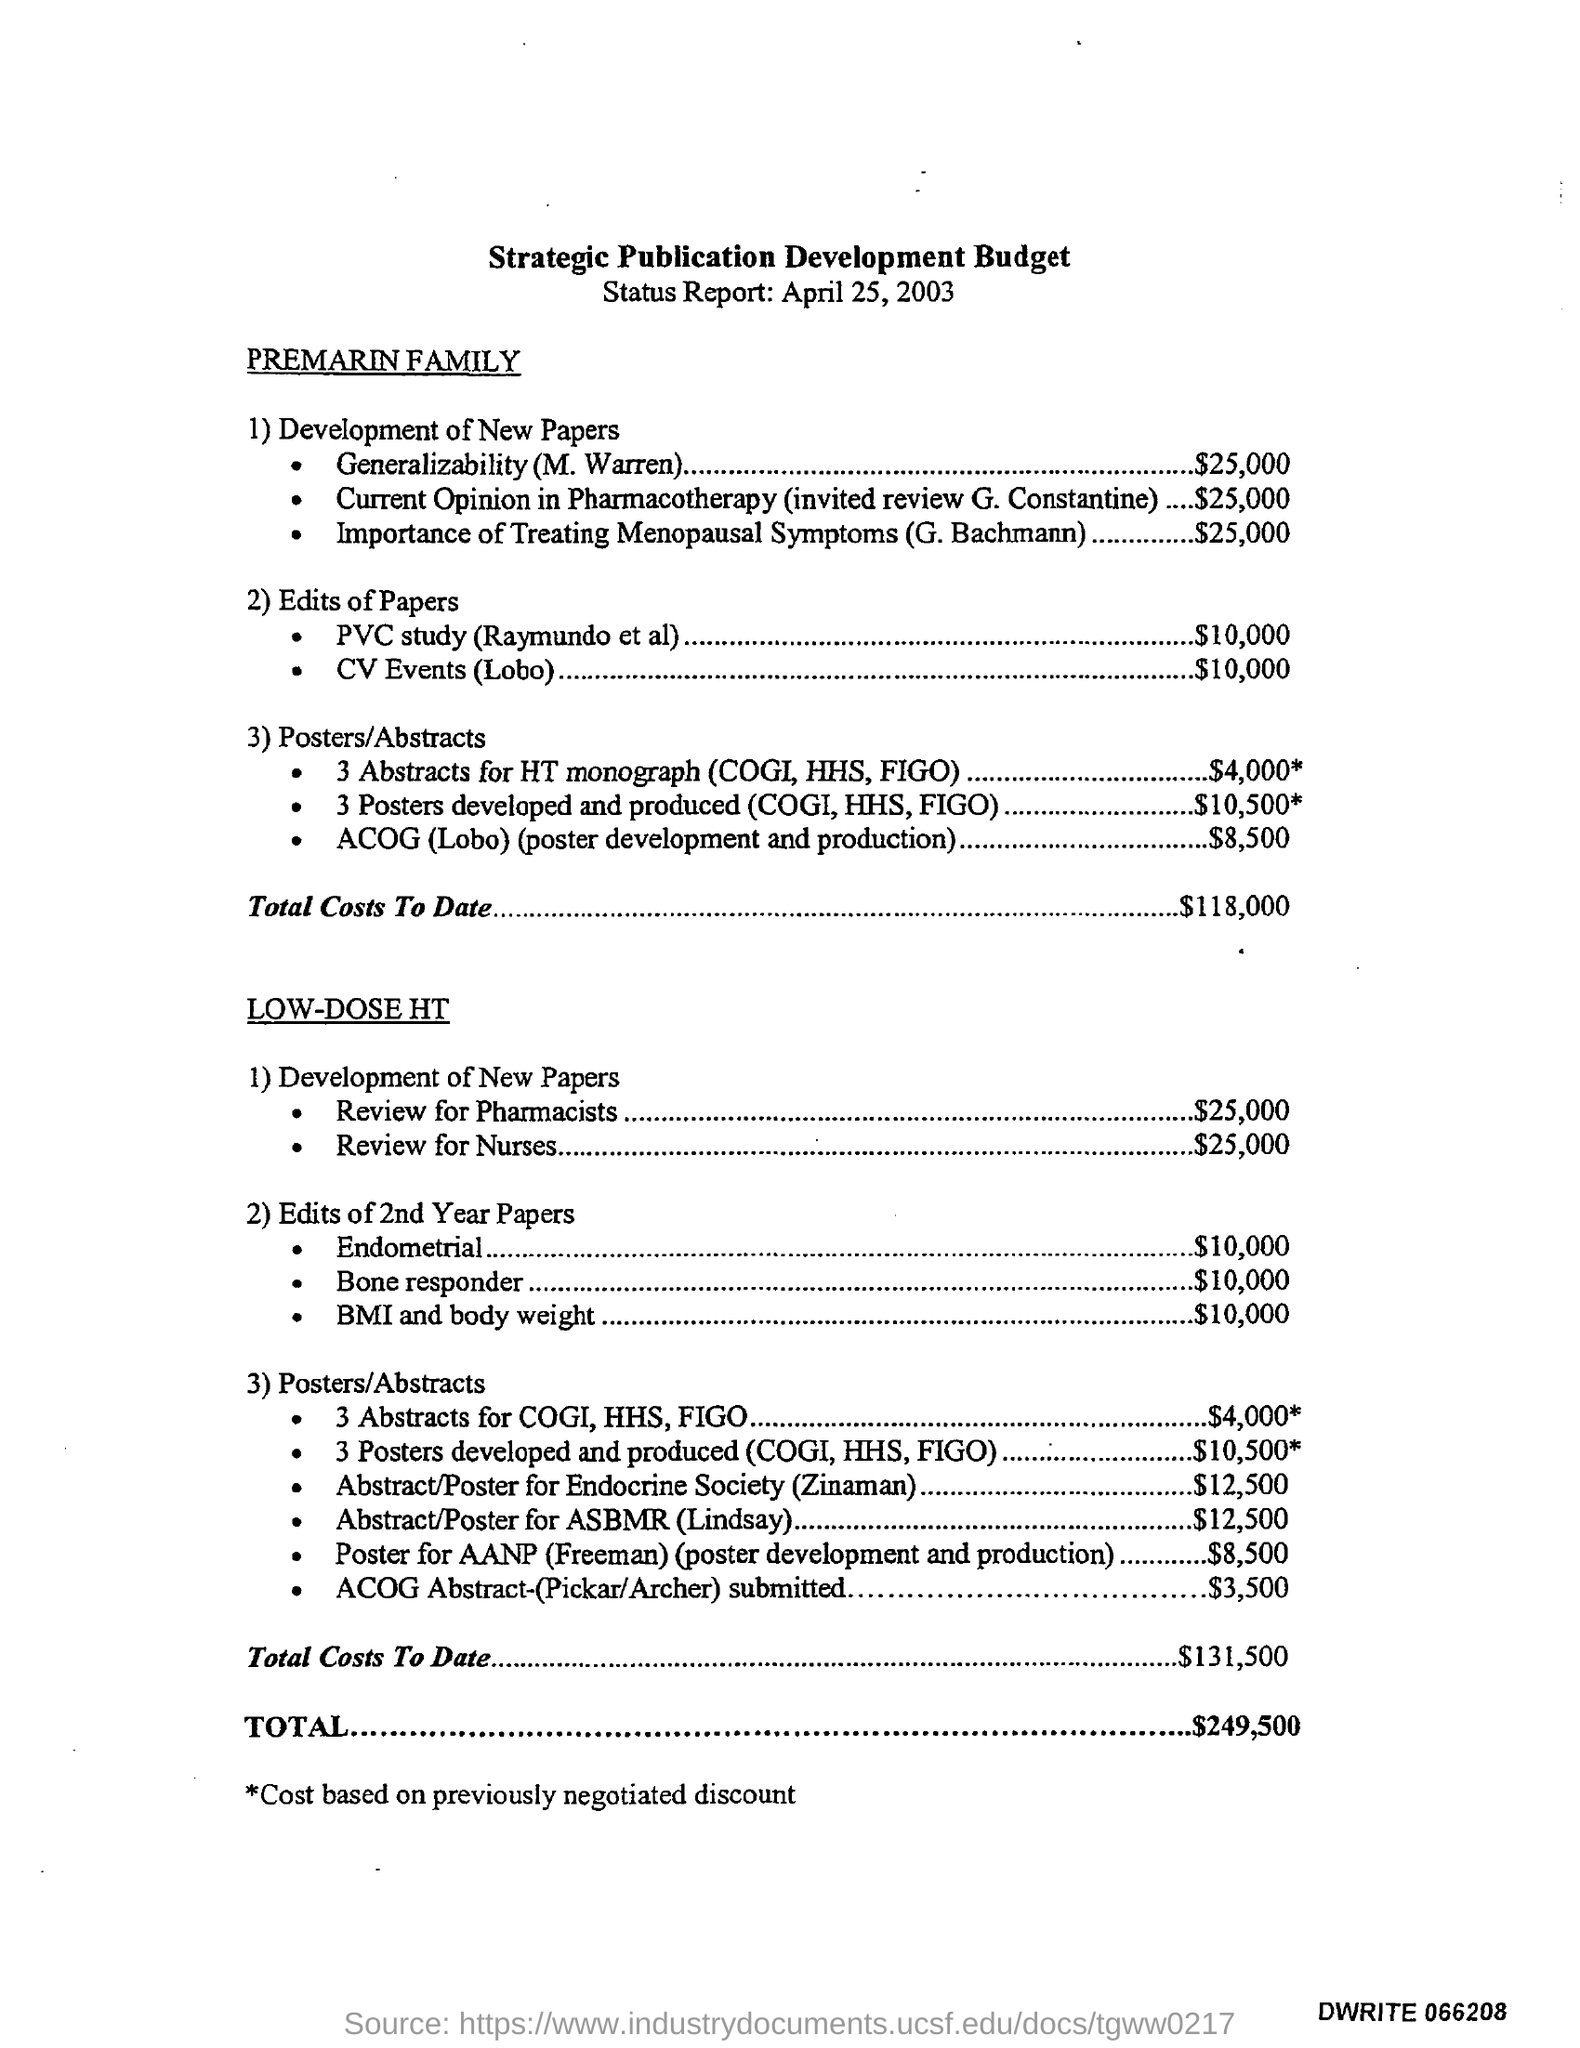What is the budget for cv events (lobo) in edits of papers ?
Provide a succinct answer. $10,000. What is the budget for pvc study in edits of papers ?
Provide a succinct answer. $10,000. What is the total budget mentioned in the given report ?
Provide a succinct answer. $249,500. 